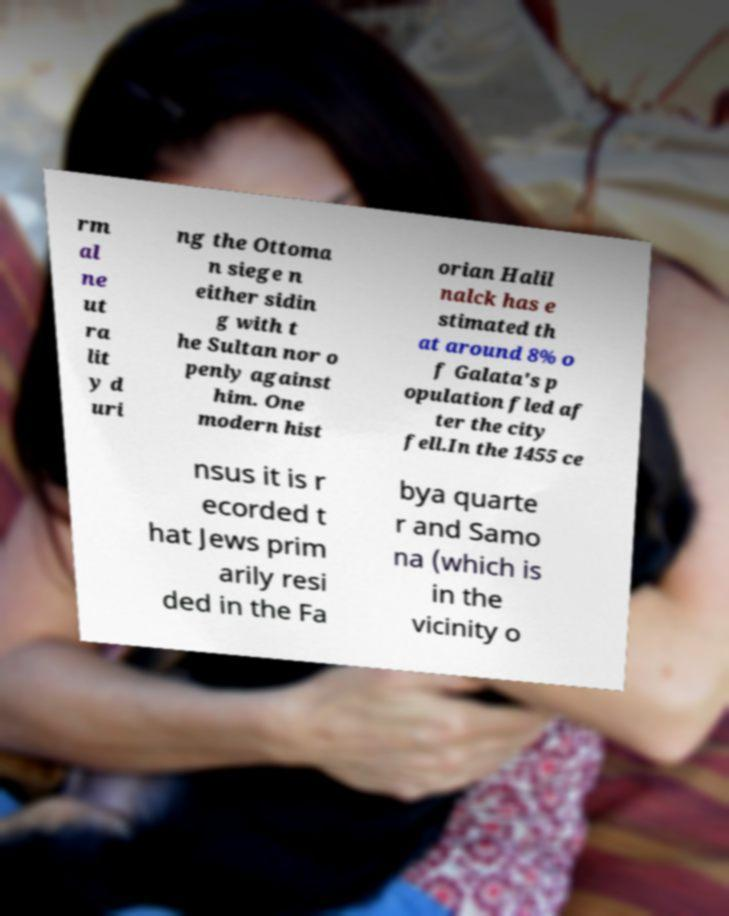Can you accurately transcribe the text from the provided image for me? rm al ne ut ra lit y d uri ng the Ottoma n siege n either sidin g with t he Sultan nor o penly against him. One modern hist orian Halil nalck has e stimated th at around 8% o f Galata's p opulation fled af ter the city fell.In the 1455 ce nsus it is r ecorded t hat Jews prim arily resi ded in the Fa bya quarte r and Samo na (which is in the vicinity o 